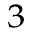<formula> <loc_0><loc_0><loc_500><loc_500>^ { 3 }</formula> 